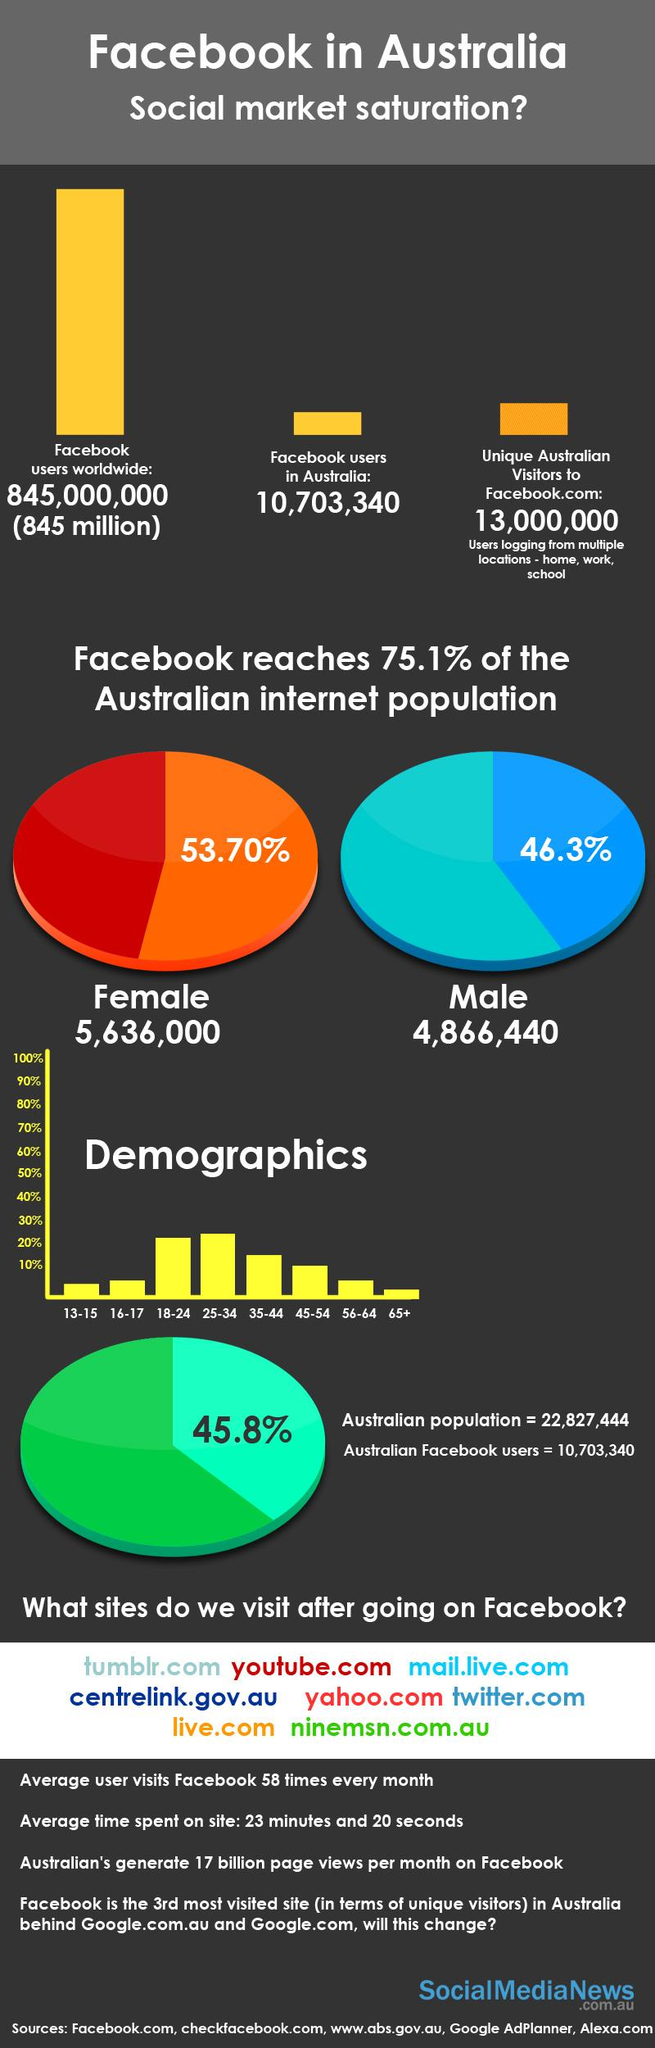Mention a couple of crucial points in this snapshot. In Australia, 46.3% of Facebook users are men. According to recent data, a significant majority of Australia's Facebook users are women, with 53.70% of users being female. The second highest number of Facebook users is in the age group of 18-24. The third highest number of Facebook users is in the age group of 35-44. 